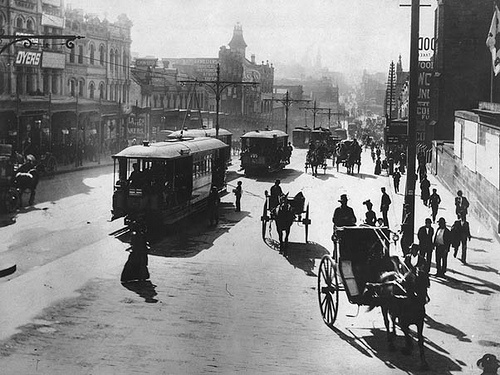Describe the objects in this image and their specific colors. I can see train in gray, black, darkgray, and lightgray tones, people in gray, black, lightgray, and darkgray tones, horse in gray, black, lightgray, and darkgray tones, train in gray, black, darkgray, and lightgray tones, and people in gray, black, darkgray, and lightgray tones in this image. 